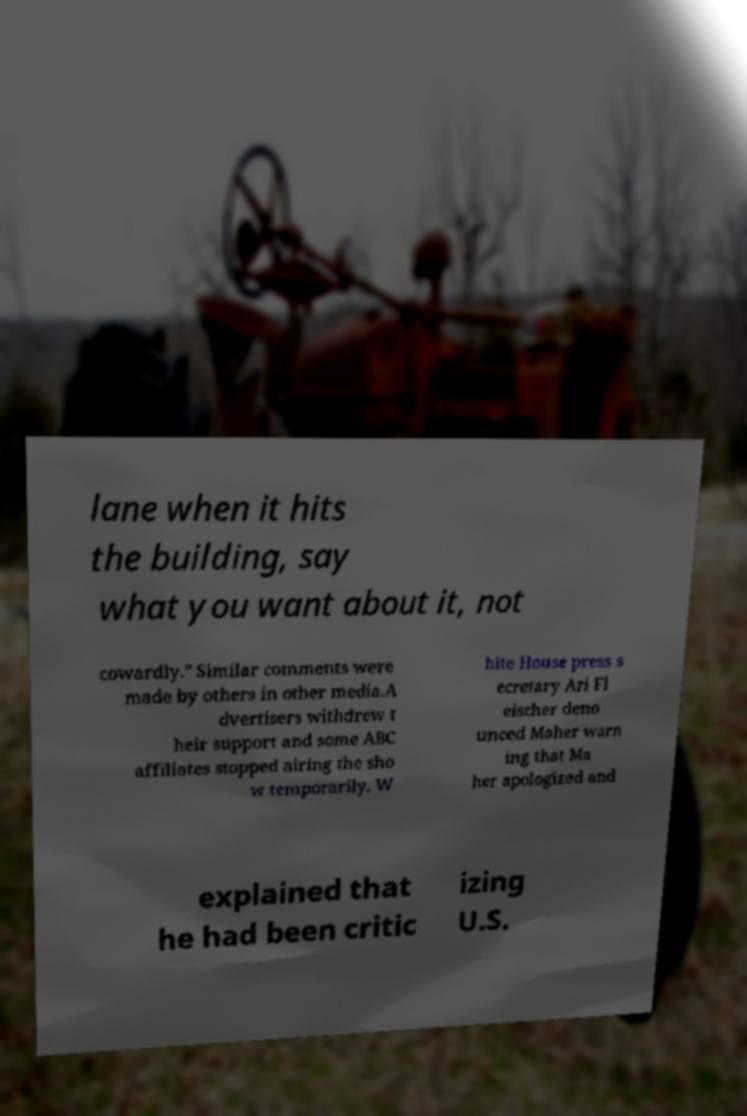For documentation purposes, I need the text within this image transcribed. Could you provide that? lane when it hits the building, say what you want about it, not cowardly." Similar comments were made by others in other media.A dvertisers withdrew t heir support and some ABC affiliates stopped airing the sho w temporarily. W hite House press s ecretary Ari Fl eischer deno unced Maher warn ing that Ma her apologized and explained that he had been critic izing U.S. 